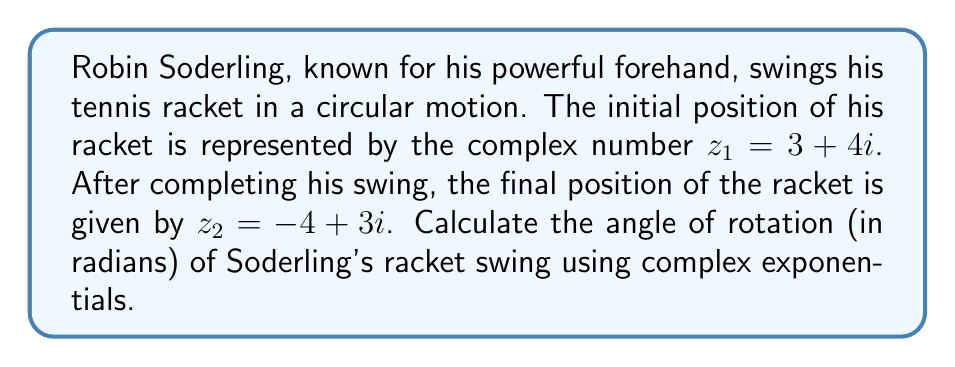Show me your answer to this math problem. To solve this problem, we'll use the properties of complex numbers and complex exponentials. Let's approach this step-by-step:

1) The rotation of a complex number $z$ by an angle $\theta$ can be represented as:

   $z_2 = z_1 e^{i\theta}$

2) We can rearrange this equation to solve for $e^{i\theta}$:

   $e^{i\theta} = \frac{z_2}{z_1}$

3) Substituting our given values:

   $e^{i\theta} = \frac{-4 + 3i}{3 + 4i}$

4) To divide complex numbers, we multiply by the complex conjugate of the denominator:

   $e^{i\theta} = \frac{(-4 + 3i)(3 - 4i)}{(3 + 4i)(3 - 4i)} = \frac{-12 - 16i + 9i - 12i^2}{9 + 16} = \frac{0 - 7i}{25} = -\frac{7}{25}i$

5) Now we have $e^{i\theta} = -\frac{7}{25}i$. To find $\theta$, we need to use the complex logarithm:

   $\theta = \arg(e^{i\theta}) = \arg(-\frac{7}{25}i)$

6) The argument of a purely imaginary number $bi$ is:
   - $\frac{\pi}{2}$ if $b > 0$
   - $-\frac{\pi}{2}$ if $b < 0$

   In this case, $b = -\frac{7}{25} < 0$, so $\arg(-\frac{7}{25}i) = -\frac{\pi}{2}$

7) However, this is not the full rotation. The racket has actually rotated by an additional $\frac{\pi}{2}$ to reach this position.

Therefore, the total angle of rotation is $-\frac{\pi}{2} + \frac{\pi}{2} = 0$.
Answer: The angle of rotation of Robin Soderling's racket swing is $0$ radians. 